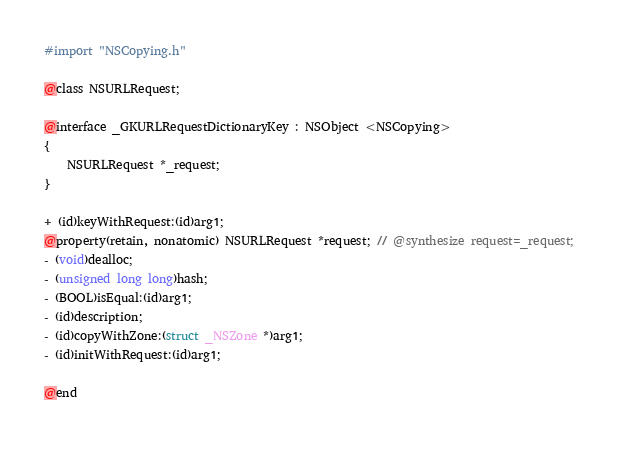<code> <loc_0><loc_0><loc_500><loc_500><_C_>#import "NSCopying.h"

@class NSURLRequest;

@interface _GKURLRequestDictionaryKey : NSObject <NSCopying>
{
    NSURLRequest *_request;
}

+ (id)keyWithRequest:(id)arg1;
@property(retain, nonatomic) NSURLRequest *request; // @synthesize request=_request;
- (void)dealloc;
- (unsigned long long)hash;
- (BOOL)isEqual:(id)arg1;
- (id)description;
- (id)copyWithZone:(struct _NSZone *)arg1;
- (id)initWithRequest:(id)arg1;

@end

</code> 